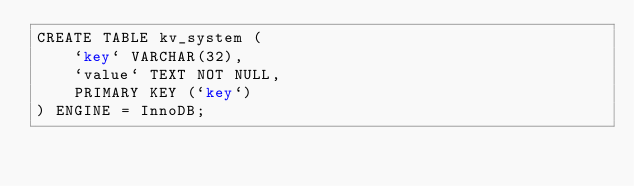<code> <loc_0><loc_0><loc_500><loc_500><_SQL_>CREATE TABLE kv_system (
    `key` VARCHAR(32),
    `value` TEXT NOT NULL,
    PRIMARY KEY (`key`)
) ENGINE = InnoDB;
</code> 